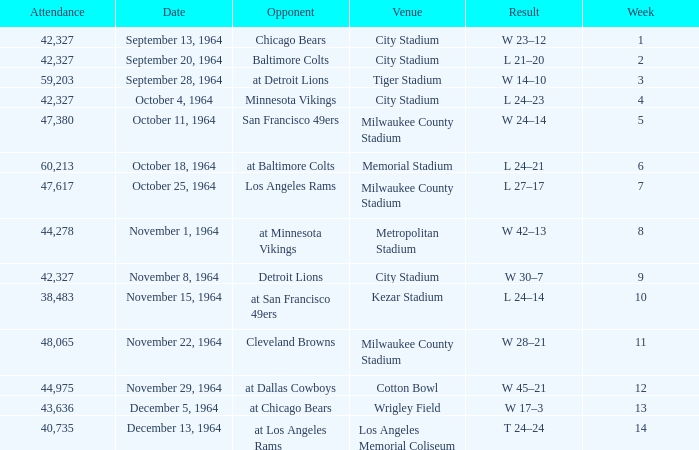What is the average attendance at a week 4 game? 42327.0. 